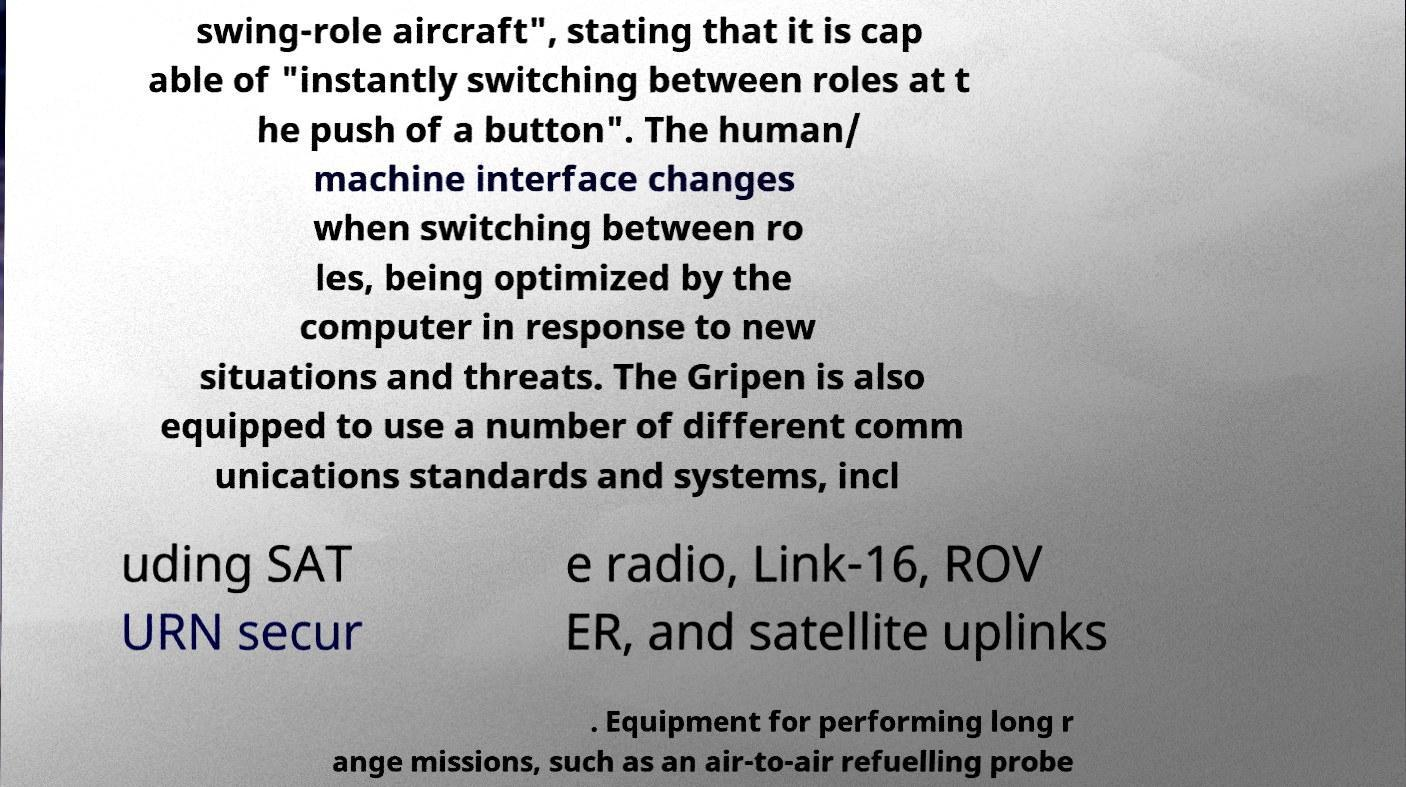Please identify and transcribe the text found in this image. swing-role aircraft", stating that it is cap able of "instantly switching between roles at t he push of a button". The human/ machine interface changes when switching between ro les, being optimized by the computer in response to new situations and threats. The Gripen is also equipped to use a number of different comm unications standards and systems, incl uding SAT URN secur e radio, Link-16, ROV ER, and satellite uplinks . Equipment for performing long r ange missions, such as an air-to-air refuelling probe 